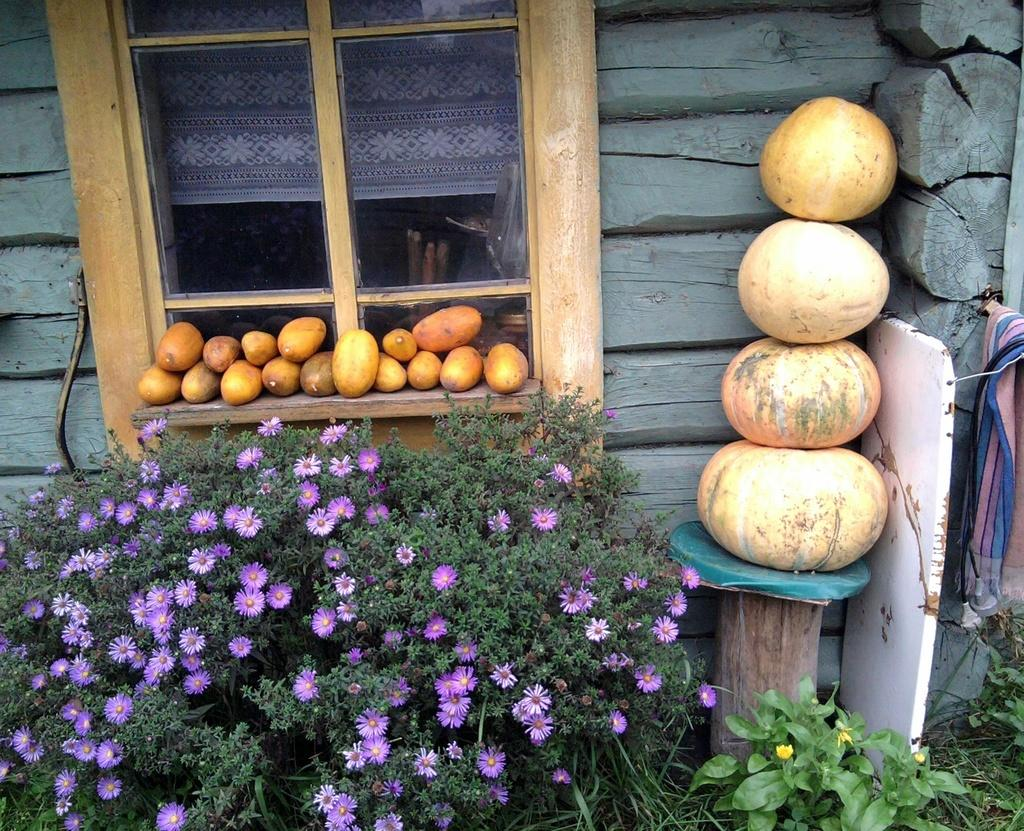What type of plants can be seen on the ground in the image? There are plants with flowers on the ground. What can be seen in the background of the image? There is a wall, a window, pumpkins, and fruits in the background of the image. What is associated with the window in the image? There is a curtain associated with the window. What type of fabric is present in the background of the image? There is a cloth in the background of the image. Can you tell me how many horns are visible on the plants in the image? There are no horns present on the plants in the image. What type of scale can be seen in the image? There is no scale present in the image. 